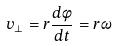Convert formula to latex. <formula><loc_0><loc_0><loc_500><loc_500>v _ { \perp } = r \frac { d \phi } { d t } = r \omega</formula> 